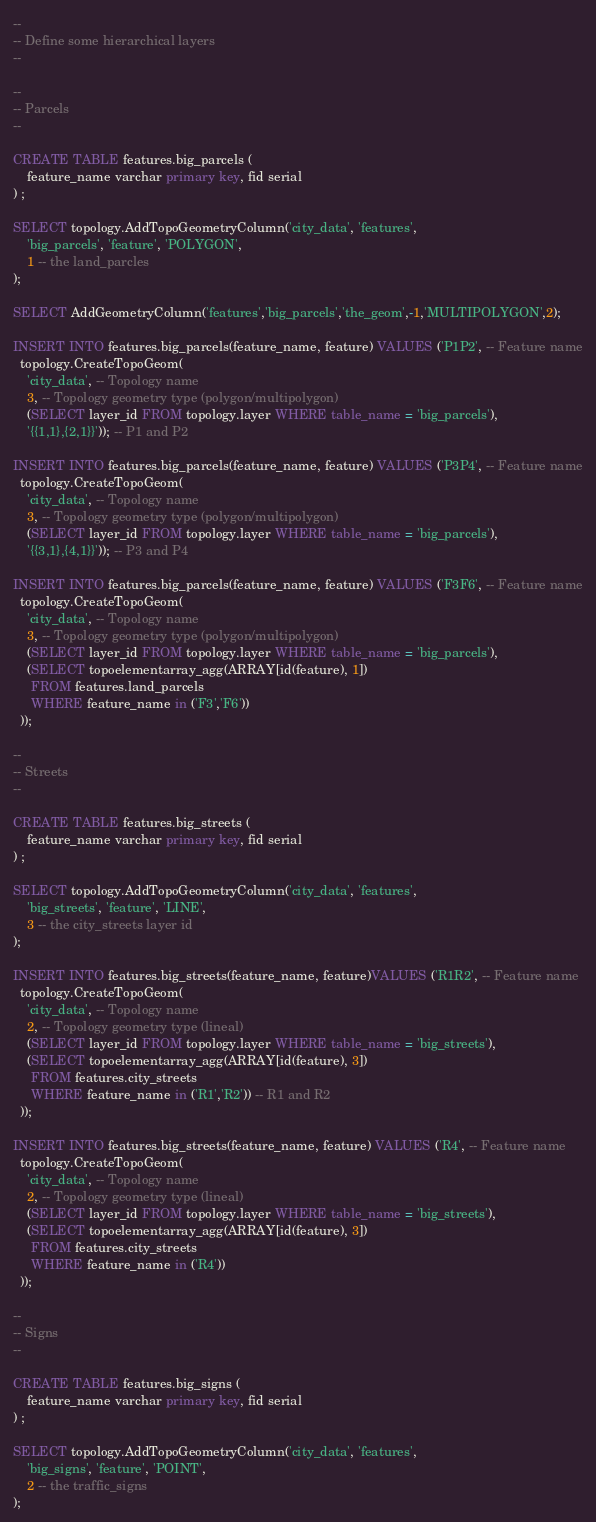<code> <loc_0><loc_0><loc_500><loc_500><_SQL_>--
-- Define some hierarchical layers
--

--
-- Parcels
--

CREATE TABLE features.big_parcels (
	feature_name varchar primary key, fid serial
) ;

SELECT topology.AddTopoGeometryColumn('city_data', 'features',
	'big_parcels', 'feature', 'POLYGON',
	1 -- the land_parcles
);

SELECT AddGeometryColumn('features','big_parcels','the_geom',-1,'MULTIPOLYGON',2);

INSERT INTO features.big_parcels(feature_name, feature) VALUES ('P1P2', -- Feature name
  topology.CreateTopoGeom(
    'city_data', -- Topology name
    3, -- Topology geometry type (polygon/multipolygon)
    (SELECT layer_id FROM topology.layer WHERE table_name = 'big_parcels'),
    '{{1,1},{2,1}}')); -- P1 and P2

INSERT INTO features.big_parcels(feature_name, feature) VALUES ('P3P4', -- Feature name
  topology.CreateTopoGeom(
    'city_data', -- Topology name
    3, -- Topology geometry type (polygon/multipolygon)
    (SELECT layer_id FROM topology.layer WHERE table_name = 'big_parcels'),
    '{{3,1},{4,1}}')); -- P3 and P4

INSERT INTO features.big_parcels(feature_name, feature) VALUES ('F3F6', -- Feature name
  topology.CreateTopoGeom(
    'city_data', -- Topology name
    3, -- Topology geometry type (polygon/multipolygon)
    (SELECT layer_id FROM topology.layer WHERE table_name = 'big_parcels'),
    (SELECT topoelementarray_agg(ARRAY[id(feature), 1])
     FROM features.land_parcels
     WHERE feature_name in ('F3','F6'))
  ));

--
-- Streets
--

CREATE TABLE features.big_streets (
	feature_name varchar primary key, fid serial
) ;

SELECT topology.AddTopoGeometryColumn('city_data', 'features',
	'big_streets', 'feature', 'LINE',
	3 -- the city_streets layer id
);

INSERT INTO features.big_streets(feature_name, feature)VALUES ('R1R2', -- Feature name
  topology.CreateTopoGeom(
    'city_data', -- Topology name
    2, -- Topology geometry type (lineal)
    (SELECT layer_id FROM topology.layer WHERE table_name = 'big_streets'),
    (SELECT topoelementarray_agg(ARRAY[id(feature), 3])
     FROM features.city_streets
     WHERE feature_name in ('R1','R2')) -- R1 and R2
  ));

INSERT INTO features.big_streets(feature_name, feature) VALUES ('R4', -- Feature name
  topology.CreateTopoGeom(
    'city_data', -- Topology name
    2, -- Topology geometry type (lineal)
    (SELECT layer_id FROM topology.layer WHERE table_name = 'big_streets'),
    (SELECT topoelementarray_agg(ARRAY[id(feature), 3])
     FROM features.city_streets
     WHERE feature_name in ('R4'))
  ));

--
-- Signs
--

CREATE TABLE features.big_signs (
	feature_name varchar primary key, fid serial
) ;

SELECT topology.AddTopoGeometryColumn('city_data', 'features',
	'big_signs', 'feature', 'POINT',
	2 -- the traffic_signs
);
</code> 